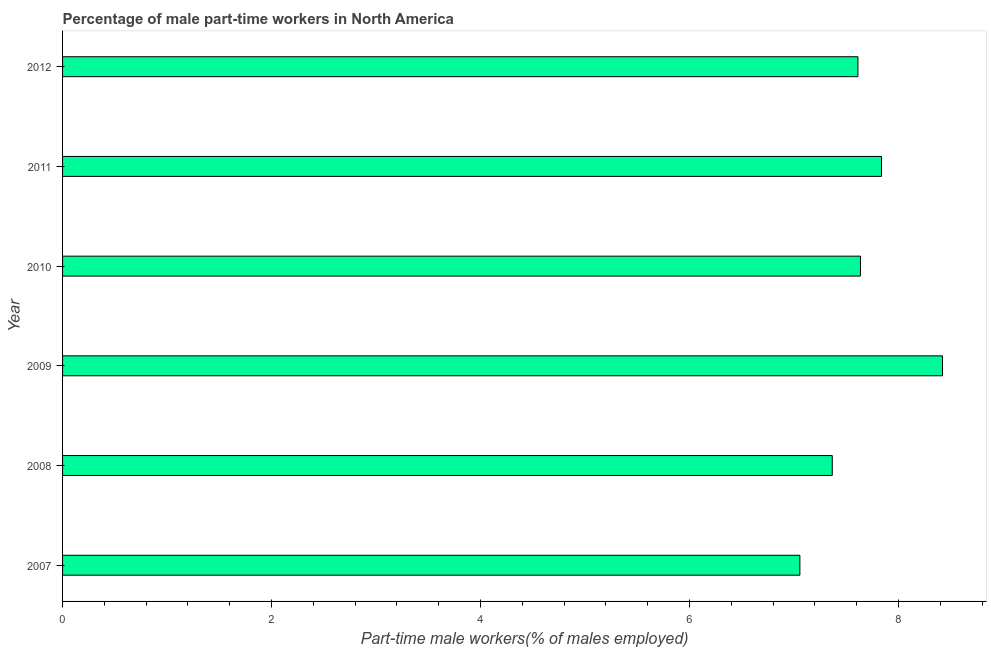Does the graph contain any zero values?
Make the answer very short. No. Does the graph contain grids?
Ensure brevity in your answer.  No. What is the title of the graph?
Provide a succinct answer. Percentage of male part-time workers in North America. What is the label or title of the X-axis?
Provide a succinct answer. Part-time male workers(% of males employed). What is the percentage of part-time male workers in 2008?
Make the answer very short. 7.37. Across all years, what is the maximum percentage of part-time male workers?
Make the answer very short. 8.42. Across all years, what is the minimum percentage of part-time male workers?
Your answer should be very brief. 7.06. In which year was the percentage of part-time male workers minimum?
Ensure brevity in your answer.  2007. What is the sum of the percentage of part-time male workers?
Keep it short and to the point. 45.93. What is the difference between the percentage of part-time male workers in 2007 and 2010?
Provide a succinct answer. -0.58. What is the average percentage of part-time male workers per year?
Your response must be concise. 7.66. What is the median percentage of part-time male workers?
Provide a succinct answer. 7.62. Do a majority of the years between 2009 and 2012 (inclusive) have percentage of part-time male workers greater than 6.4 %?
Offer a terse response. Yes. What is the ratio of the percentage of part-time male workers in 2007 to that in 2009?
Give a very brief answer. 0.84. Is the percentage of part-time male workers in 2008 less than that in 2010?
Give a very brief answer. Yes. What is the difference between the highest and the second highest percentage of part-time male workers?
Offer a terse response. 0.58. Is the sum of the percentage of part-time male workers in 2009 and 2011 greater than the maximum percentage of part-time male workers across all years?
Your answer should be very brief. Yes. What is the difference between the highest and the lowest percentage of part-time male workers?
Keep it short and to the point. 1.36. In how many years, is the percentage of part-time male workers greater than the average percentage of part-time male workers taken over all years?
Keep it short and to the point. 2. What is the Part-time male workers(% of males employed) in 2007?
Give a very brief answer. 7.06. What is the Part-time male workers(% of males employed) in 2008?
Ensure brevity in your answer.  7.37. What is the Part-time male workers(% of males employed) in 2009?
Offer a very short reply. 8.42. What is the Part-time male workers(% of males employed) in 2010?
Provide a succinct answer. 7.64. What is the Part-time male workers(% of males employed) of 2011?
Offer a very short reply. 7.84. What is the Part-time male workers(% of males employed) in 2012?
Provide a short and direct response. 7.61. What is the difference between the Part-time male workers(% of males employed) in 2007 and 2008?
Provide a short and direct response. -0.31. What is the difference between the Part-time male workers(% of males employed) in 2007 and 2009?
Offer a very short reply. -1.36. What is the difference between the Part-time male workers(% of males employed) in 2007 and 2010?
Your response must be concise. -0.58. What is the difference between the Part-time male workers(% of males employed) in 2007 and 2011?
Provide a succinct answer. -0.78. What is the difference between the Part-time male workers(% of males employed) in 2007 and 2012?
Give a very brief answer. -0.56. What is the difference between the Part-time male workers(% of males employed) in 2008 and 2009?
Provide a short and direct response. -1.05. What is the difference between the Part-time male workers(% of males employed) in 2008 and 2010?
Provide a succinct answer. -0.27. What is the difference between the Part-time male workers(% of males employed) in 2008 and 2011?
Make the answer very short. -0.47. What is the difference between the Part-time male workers(% of males employed) in 2008 and 2012?
Provide a short and direct response. -0.25. What is the difference between the Part-time male workers(% of males employed) in 2009 and 2010?
Offer a terse response. 0.79. What is the difference between the Part-time male workers(% of males employed) in 2009 and 2011?
Your answer should be compact. 0.58. What is the difference between the Part-time male workers(% of males employed) in 2009 and 2012?
Your answer should be compact. 0.81. What is the difference between the Part-time male workers(% of males employed) in 2010 and 2011?
Ensure brevity in your answer.  -0.2. What is the difference between the Part-time male workers(% of males employed) in 2010 and 2012?
Offer a very short reply. 0.02. What is the difference between the Part-time male workers(% of males employed) in 2011 and 2012?
Ensure brevity in your answer.  0.23. What is the ratio of the Part-time male workers(% of males employed) in 2007 to that in 2008?
Give a very brief answer. 0.96. What is the ratio of the Part-time male workers(% of males employed) in 2007 to that in 2009?
Make the answer very short. 0.84. What is the ratio of the Part-time male workers(% of males employed) in 2007 to that in 2010?
Provide a succinct answer. 0.92. What is the ratio of the Part-time male workers(% of males employed) in 2007 to that in 2011?
Provide a short and direct response. 0.9. What is the ratio of the Part-time male workers(% of males employed) in 2007 to that in 2012?
Provide a succinct answer. 0.93. What is the ratio of the Part-time male workers(% of males employed) in 2008 to that in 2009?
Your answer should be compact. 0.88. What is the ratio of the Part-time male workers(% of males employed) in 2008 to that in 2011?
Offer a very short reply. 0.94. What is the ratio of the Part-time male workers(% of males employed) in 2009 to that in 2010?
Offer a terse response. 1.1. What is the ratio of the Part-time male workers(% of males employed) in 2009 to that in 2011?
Your answer should be compact. 1.07. What is the ratio of the Part-time male workers(% of males employed) in 2009 to that in 2012?
Your response must be concise. 1.11. What is the ratio of the Part-time male workers(% of males employed) in 2010 to that in 2011?
Offer a terse response. 0.97. What is the ratio of the Part-time male workers(% of males employed) in 2010 to that in 2012?
Offer a terse response. 1. What is the ratio of the Part-time male workers(% of males employed) in 2011 to that in 2012?
Provide a short and direct response. 1.03. 